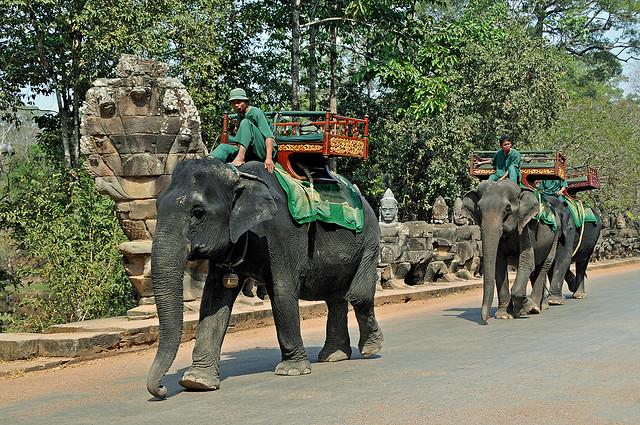Are these all the same type of animal?
Write a very short answer. Yes. Is this in India?
Quick response, please. Yes. How many passengers are they carrying?
Write a very short answer. 2. 